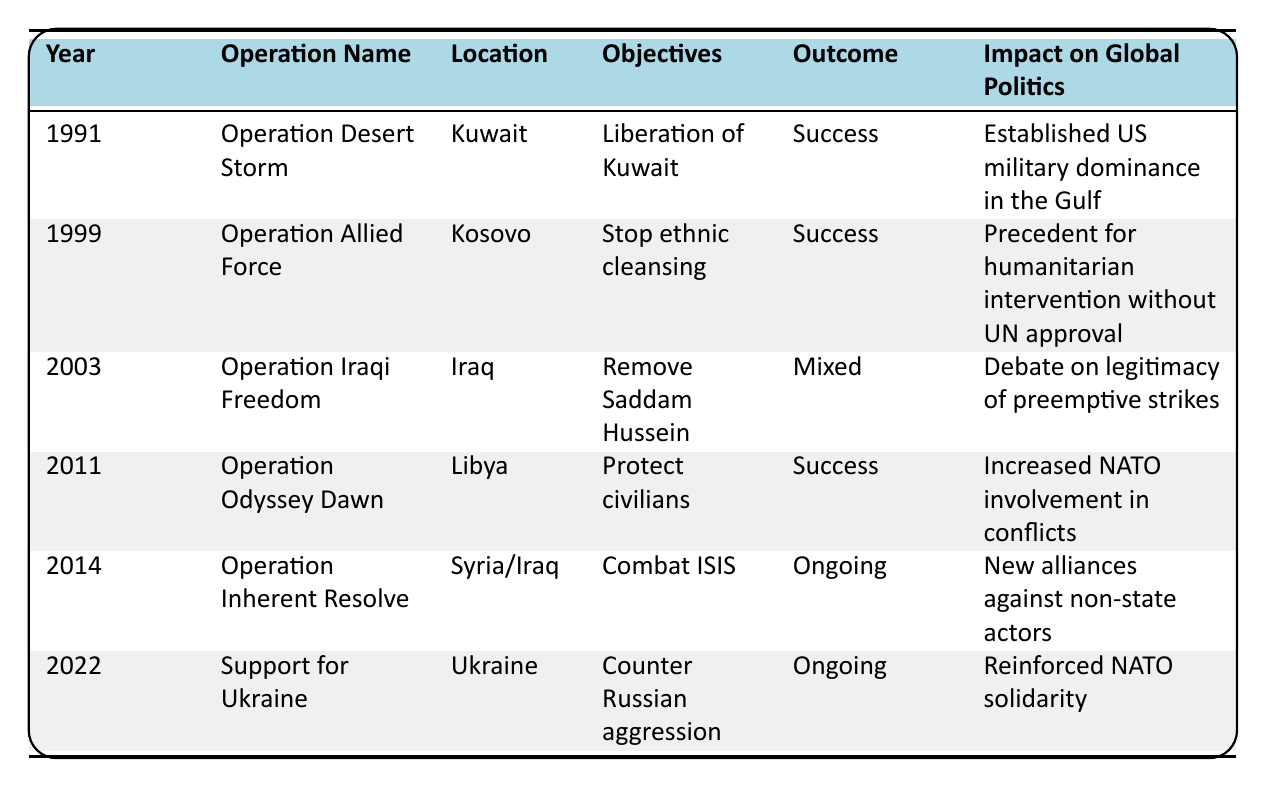What year did Operation Desert Storm take place? From the table, the row corresponding to Operation Desert Storm lists the year as 1991.
Answer: 1991 What was the objective of Operation Restore Hope? Looking at the row for Operation Restore Hope, the objectives listed are "Humanitarian aid" and "Stabilization of government".
Answer: Humanitarian aid and Stabilization of government What was the outcome of Operation Iraqi Freedom? The table specifies that the outcome of Operation Iraqi Freedom was "Mixed".
Answer: Mixed Which operation emphasized the challenges of humanitarian interventions? The table indicates that Operation Restore Hope highlighted challenges of humanitarian interventions.
Answer: Operation Restore Hope In how many operations did the United States seek to combat ISIS? The table reveals that there was only one operation, Operation Inherent Resolve, aimed at combating ISIS.
Answer: One Was Operation Allied Force successful? According to the table, Operation Allied Force had an outcome labeled as "Success".
Answer: Yes What is the impact on global politics of Operation Odyssey Dawn? The table states that Operation Odyssey Dawn increased NATO involvement in conflicts, indicating its political impact.
Answer: Increased NATO involvement in conflicts Which operation was characterized by ongoing efforts and aimed at stabilizing Iraq and Syria? The table shows that Operation Inherent Resolve is ongoing and aims to stabilize the region.
Answer: Operation Inherent Resolve How many military interventions are listed as ongoing in the table? There are three operations listed as ongoing: Operation Enduring Freedom, Operation Inherent Resolve, and Support for Ukraine.
Answer: Three What is the significance of Operation Desert Storm in terms of U.S. military presence? The table notes that it established U.S. military dominance in the Gulf.
Answer: Established U.S. military dominance in the Gulf What operation occurred in the same year as the evacuation of Afghanistan? The only operation listed for 2021 is the "Evacuation of Afghanistan."
Answer: Evacuation of Afghanistan How does the outcome of Operation Truman differ from that of Operation Iraqi Freedom? The table states that Operation Restore Hope had a "Partial Success" outcome, while Operation Iraqi Freedom had a "Mixed" outcome.
Answer: Operation Restore Hope: Partial Success; Operation Iraqi Freedom: Mixed Did Operation Support for Ukraine have any stated impact on NATO? Yes, the table mentions it reinforced NATO solidarity and geopolitical balances.
Answer: Yes Which intervention aimed to protect civilians and support regime change? The table indicates that Operation Odyssey Dawn had objectives that included protecting civilians and supporting regime change.
Answer: Operation Odyssey Dawn What are the years in which the U.S. military interventions were declared successful? The table identifies successful operations in the years 1991, 1999, 2011.
Answer: 1991, 1999, 2011 What were the objectives of Operation Enduring Freedom? From the table, the objectives of Operation Enduring Freedom are "Dismantle Al-Qaeda" and "Remove Taliban from power."
Answer: Dismantle Al-Qaeda and Remove Taliban from power 